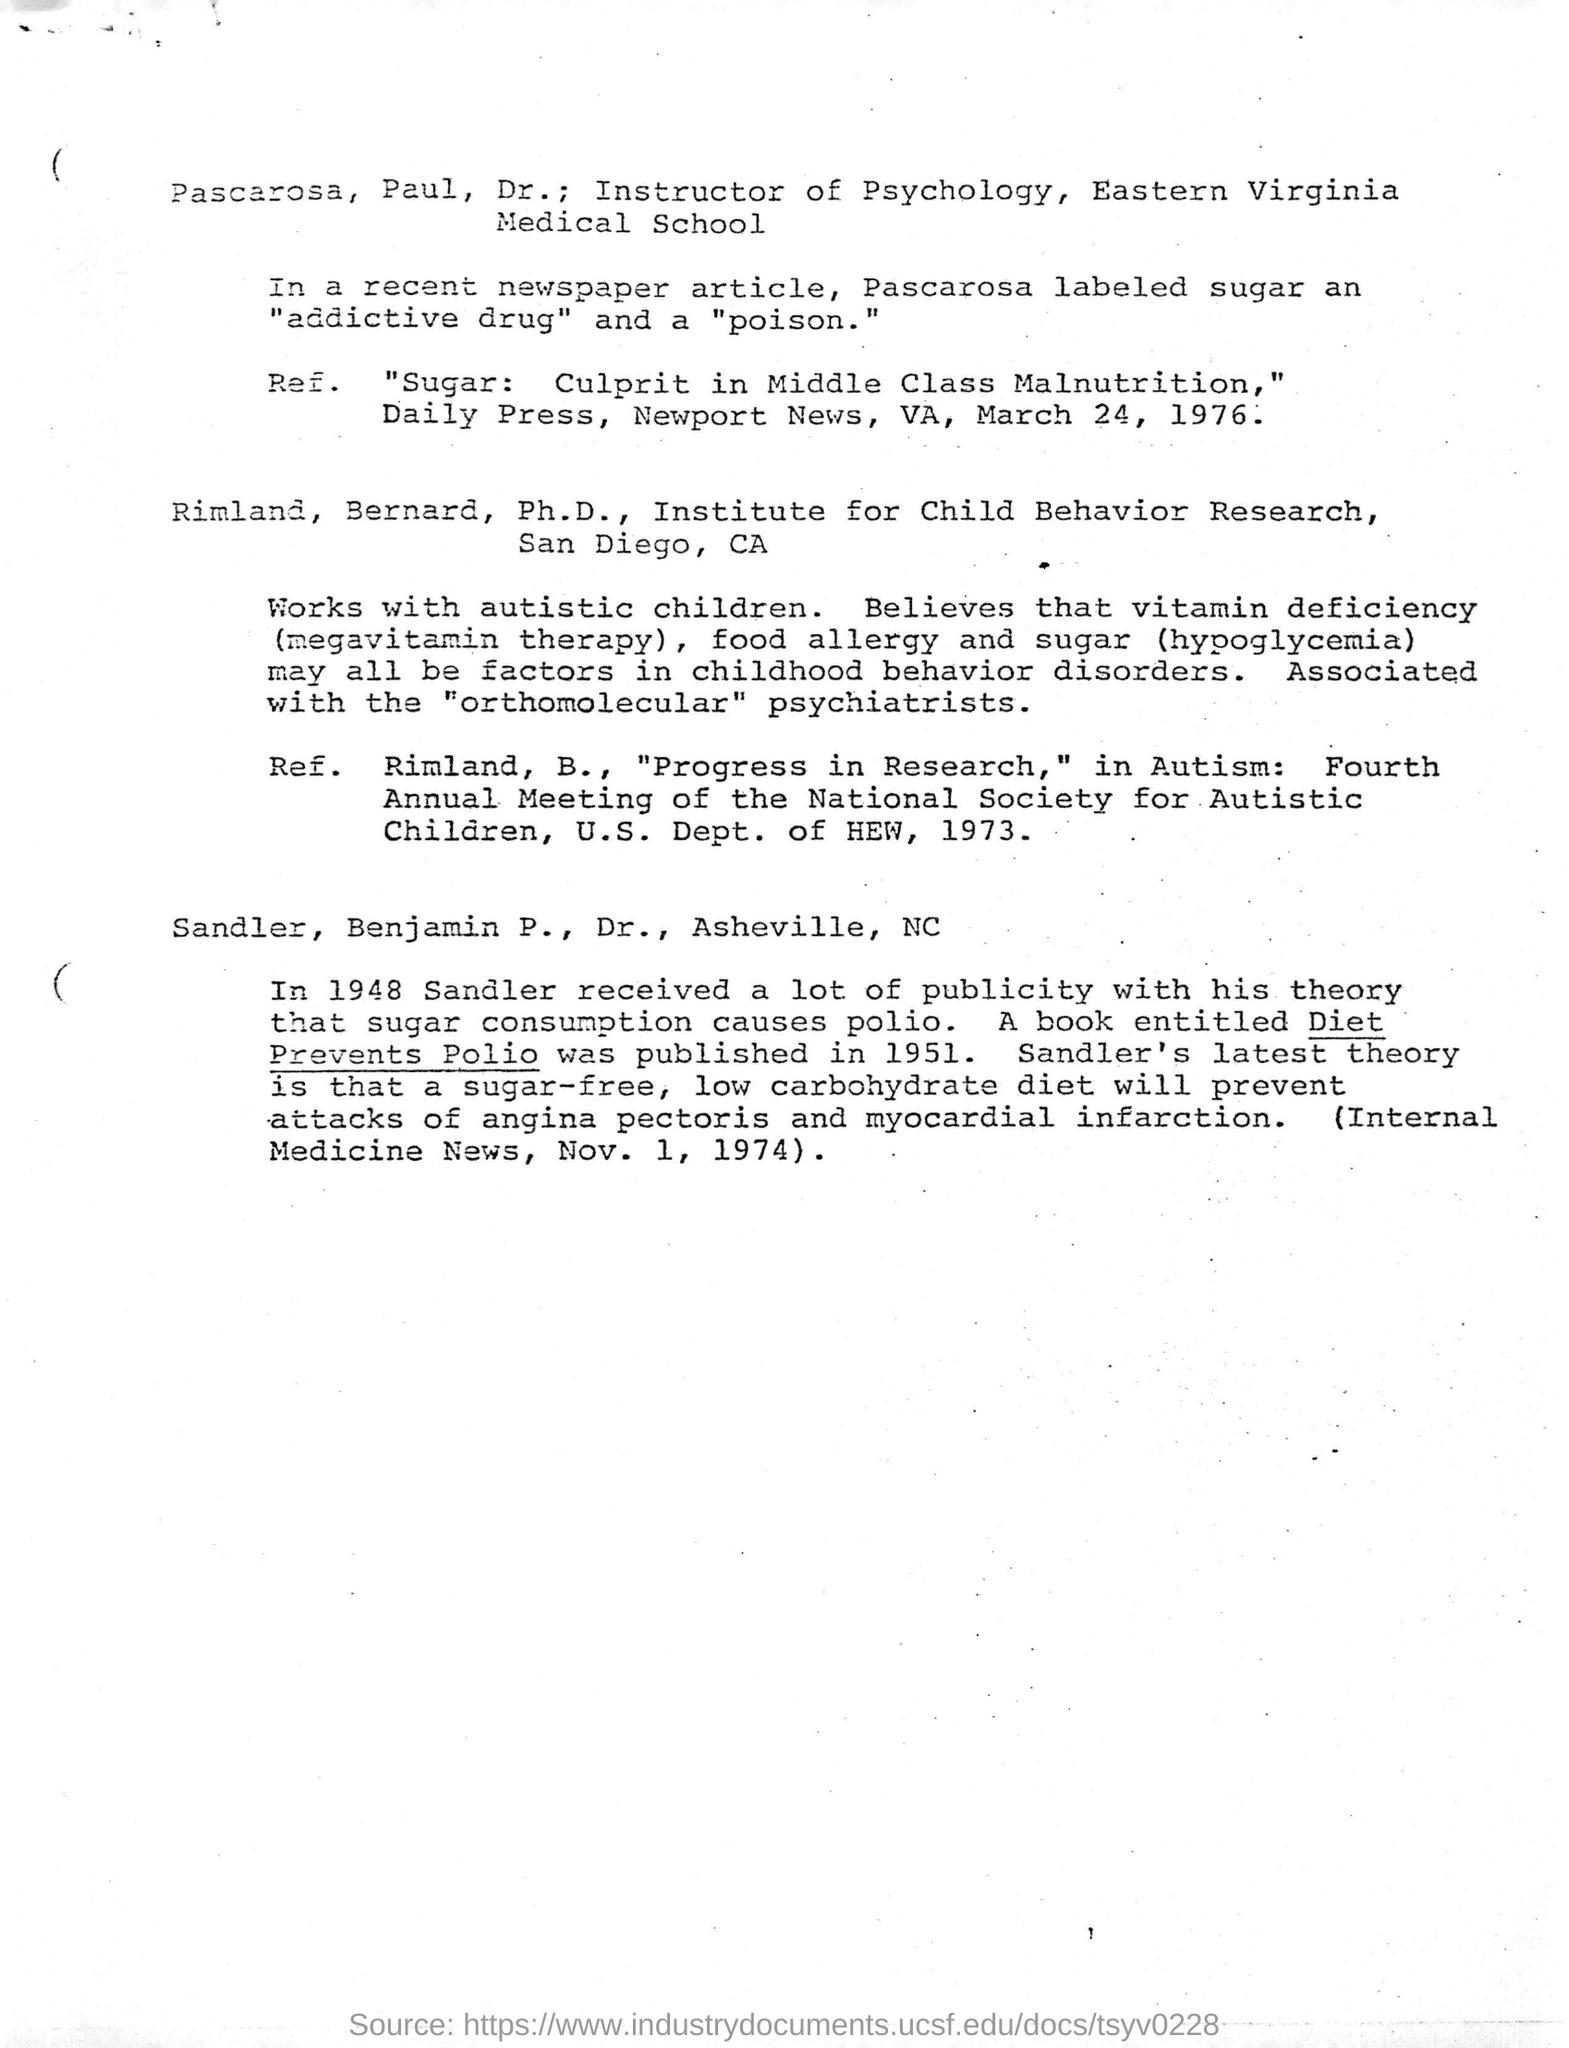Highlight a few significant elements in this photo. A theory that sugar consumption can cause polio was publicized by Dr. Sandler, who is a doctor based in Asheville, North Carolina. Pascarosa Labeled sugar was recently referred to as an addictive drug and a poison in a newspaper article. In 1951, a book entitled "Diet Prevents Polio" was published. Dr. Pascarosa Paul, an instructor of Psychology at Eastern Virginia Medical School, is a well-known professional in the field. 